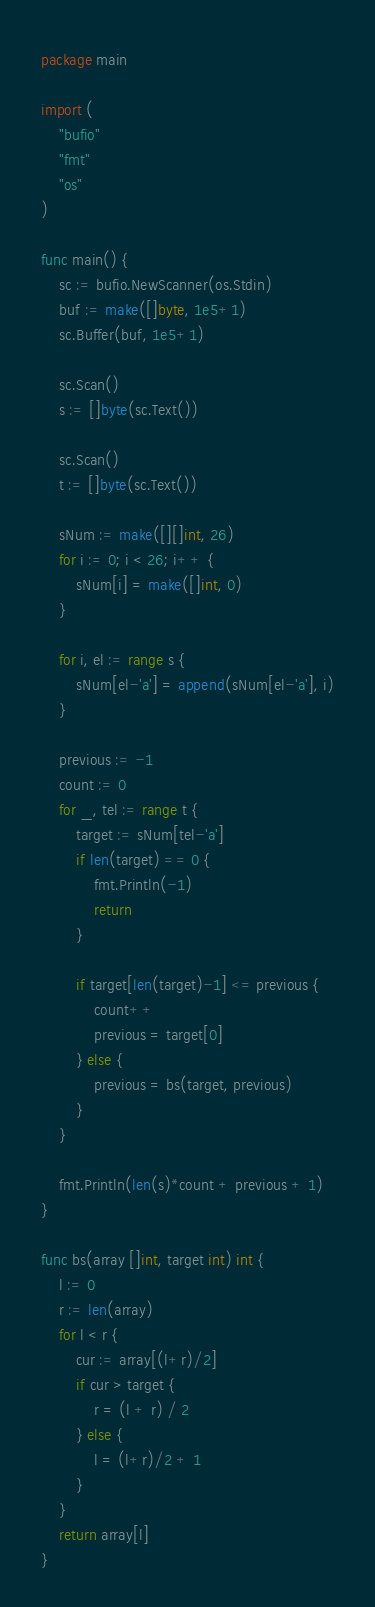<code> <loc_0><loc_0><loc_500><loc_500><_Go_>package main

import (
	"bufio"
	"fmt"
	"os"
)

func main() {
	sc := bufio.NewScanner(os.Stdin)
	buf := make([]byte, 1e5+1)
	sc.Buffer(buf, 1e5+1)

	sc.Scan()
	s := []byte(sc.Text())

	sc.Scan()
	t := []byte(sc.Text())

	sNum := make([][]int, 26)
	for i := 0; i < 26; i++ {
		sNum[i] = make([]int, 0)
	}

	for i, el := range s {
		sNum[el-'a'] = append(sNum[el-'a'], i)
	}

	previous := -1
	count := 0
	for _, tel := range t {
		target := sNum[tel-'a']
		if len(target) == 0 {
			fmt.Println(-1)
			return
		}

		if target[len(target)-1] <= previous {
			count++
			previous = target[0]
		} else {
			previous = bs(target, previous)
		}
	}

	fmt.Println(len(s)*count + previous + 1)
}

func bs(array []int, target int) int {
	l := 0
	r := len(array)
	for l < r {
		cur := array[(l+r)/2]
		if cur > target {
			r = (l + r) / 2
		} else {
			l = (l+r)/2 + 1
		}
	}
	return array[l]
}
</code> 